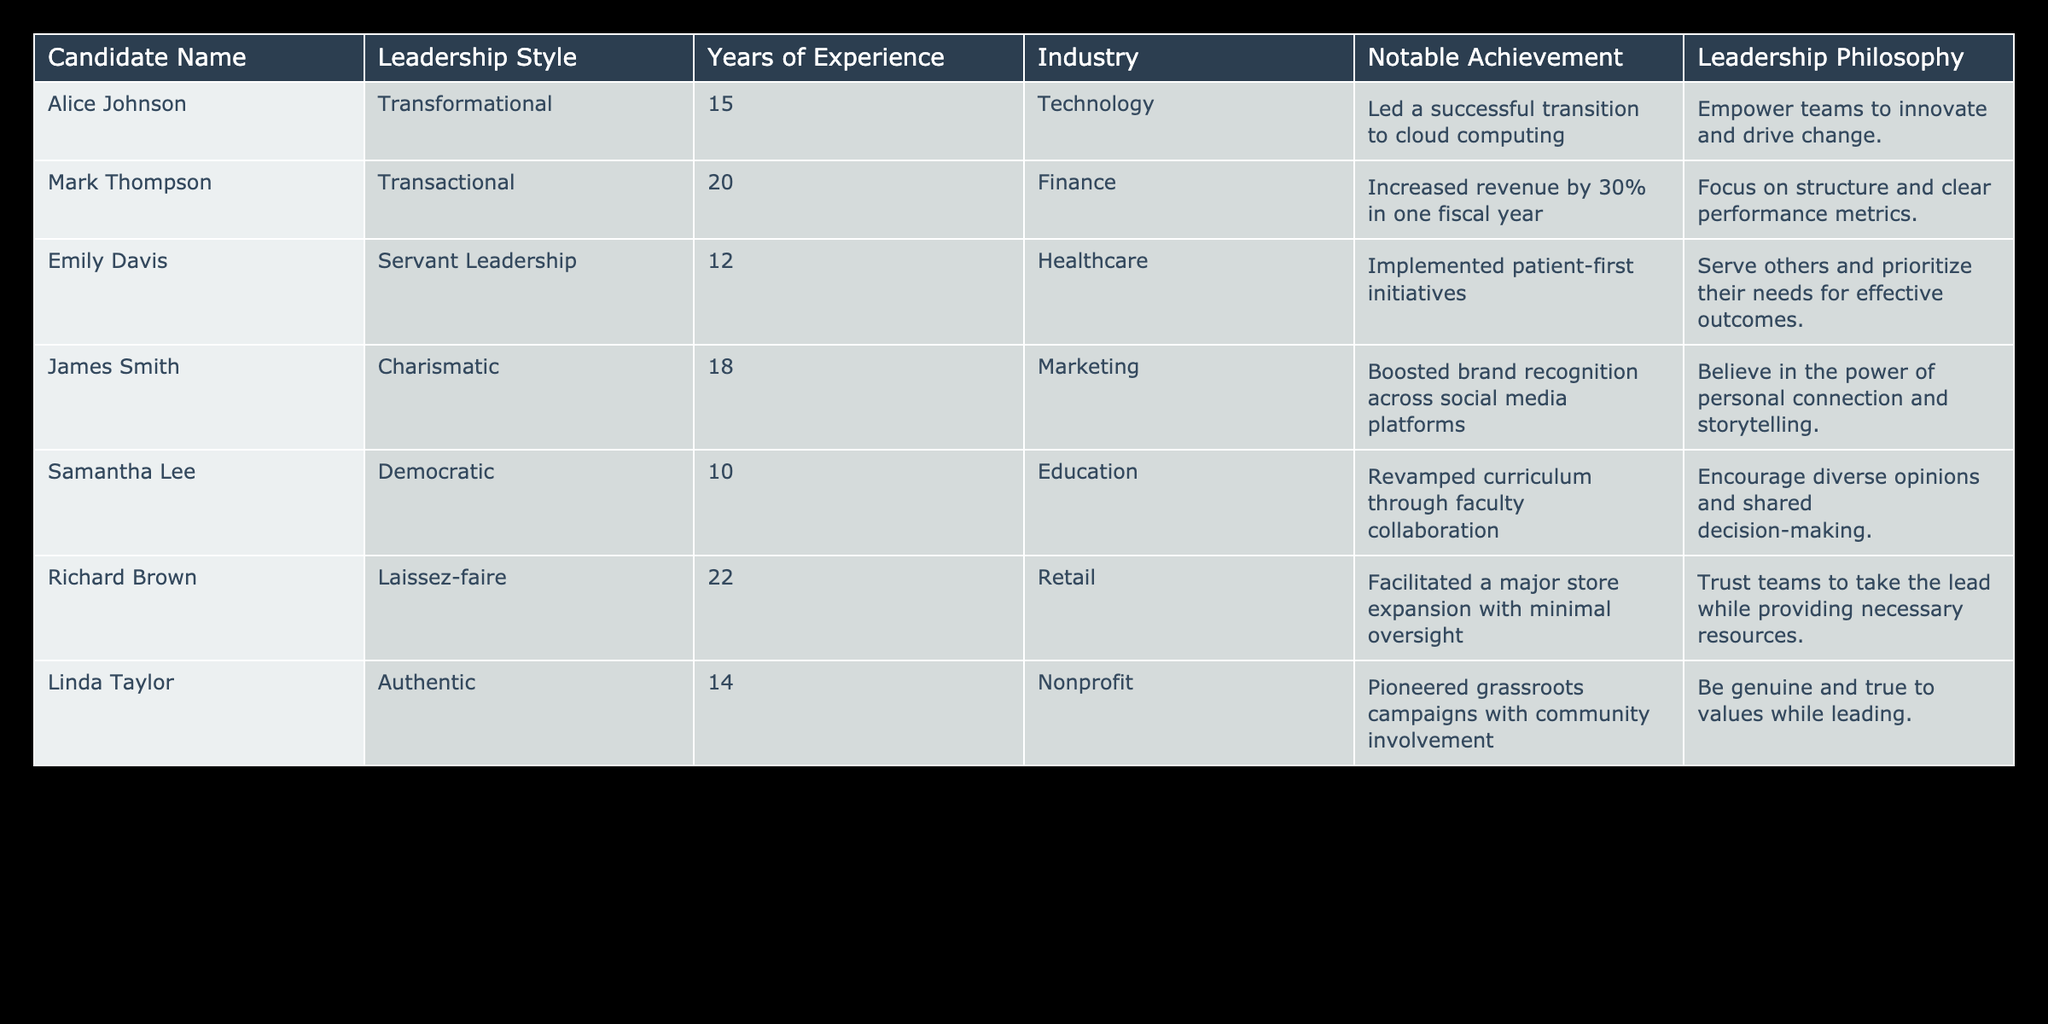What is the leadership style of Alice Johnson? Alice Johnson's row is examined in the table, where it clearly states her leadership style as Transformational.
Answer: Transformational Who has the most years of experience among the candidates? By reviewing the Years of Experience column, Richard Brown has the highest value listed at 22 years.
Answer: 22 Which candidate is associated with the healthcare industry? Looking at the Industry column, Emily Davis is the only candidate listed under Healthcare.
Answer: Emily Davis What is the average years of experience among all candidates? Summing the Years of Experience values gives a total of 15 + 20 + 12 + 18 + 10 + 22 + 14 = 111 years. Dividing by the number of candidates (7) yields an average of 111 / 7 = 15.857, which can be rounded to 15.86.
Answer: 15.86 Is James Smith known for any notable achievement related to technology? Checking the Notable Achievement column reveals that James Smith's achievement pertains to marketing, not technology.
Answer: No Which leadership philosophy emphasizes team empowerment and innovation? The Leadership Philosophy column shows that Alice Johnson's philosophy is about empowerment and innovation.
Answer: Alice Johnson's philosophy Identify the leadership style of the candidate with the notable achievement of increasing revenue by 30%. The table indicates that Mark Thompson achieved the revenue increase, and his listed leadership style is Transactional.
Answer: Transactional Are there any candidates who practice Servant Leadership with over 15 years of experience? Emily Davis practices Servant Leadership but has only 12 years of experience, which doesn't meet the criterion of over 15 years. Therefore, there are no candidates that fit this requirement.
Answer: No What is the notable achievement of Linda Taylor? By looking at the Notable Achievement column, Linda Taylor is noted for pioneering grassroots campaigns with community involvement.
Answer: Pioneered grassroots campaigns with community involvement Which candidate has a leadership philosophy that focuses on shared decision-making? The table specifies that Samantha Lee encourages diverse opinions and shared decision-making as her leadership philosophy.
Answer: Samantha Lee 